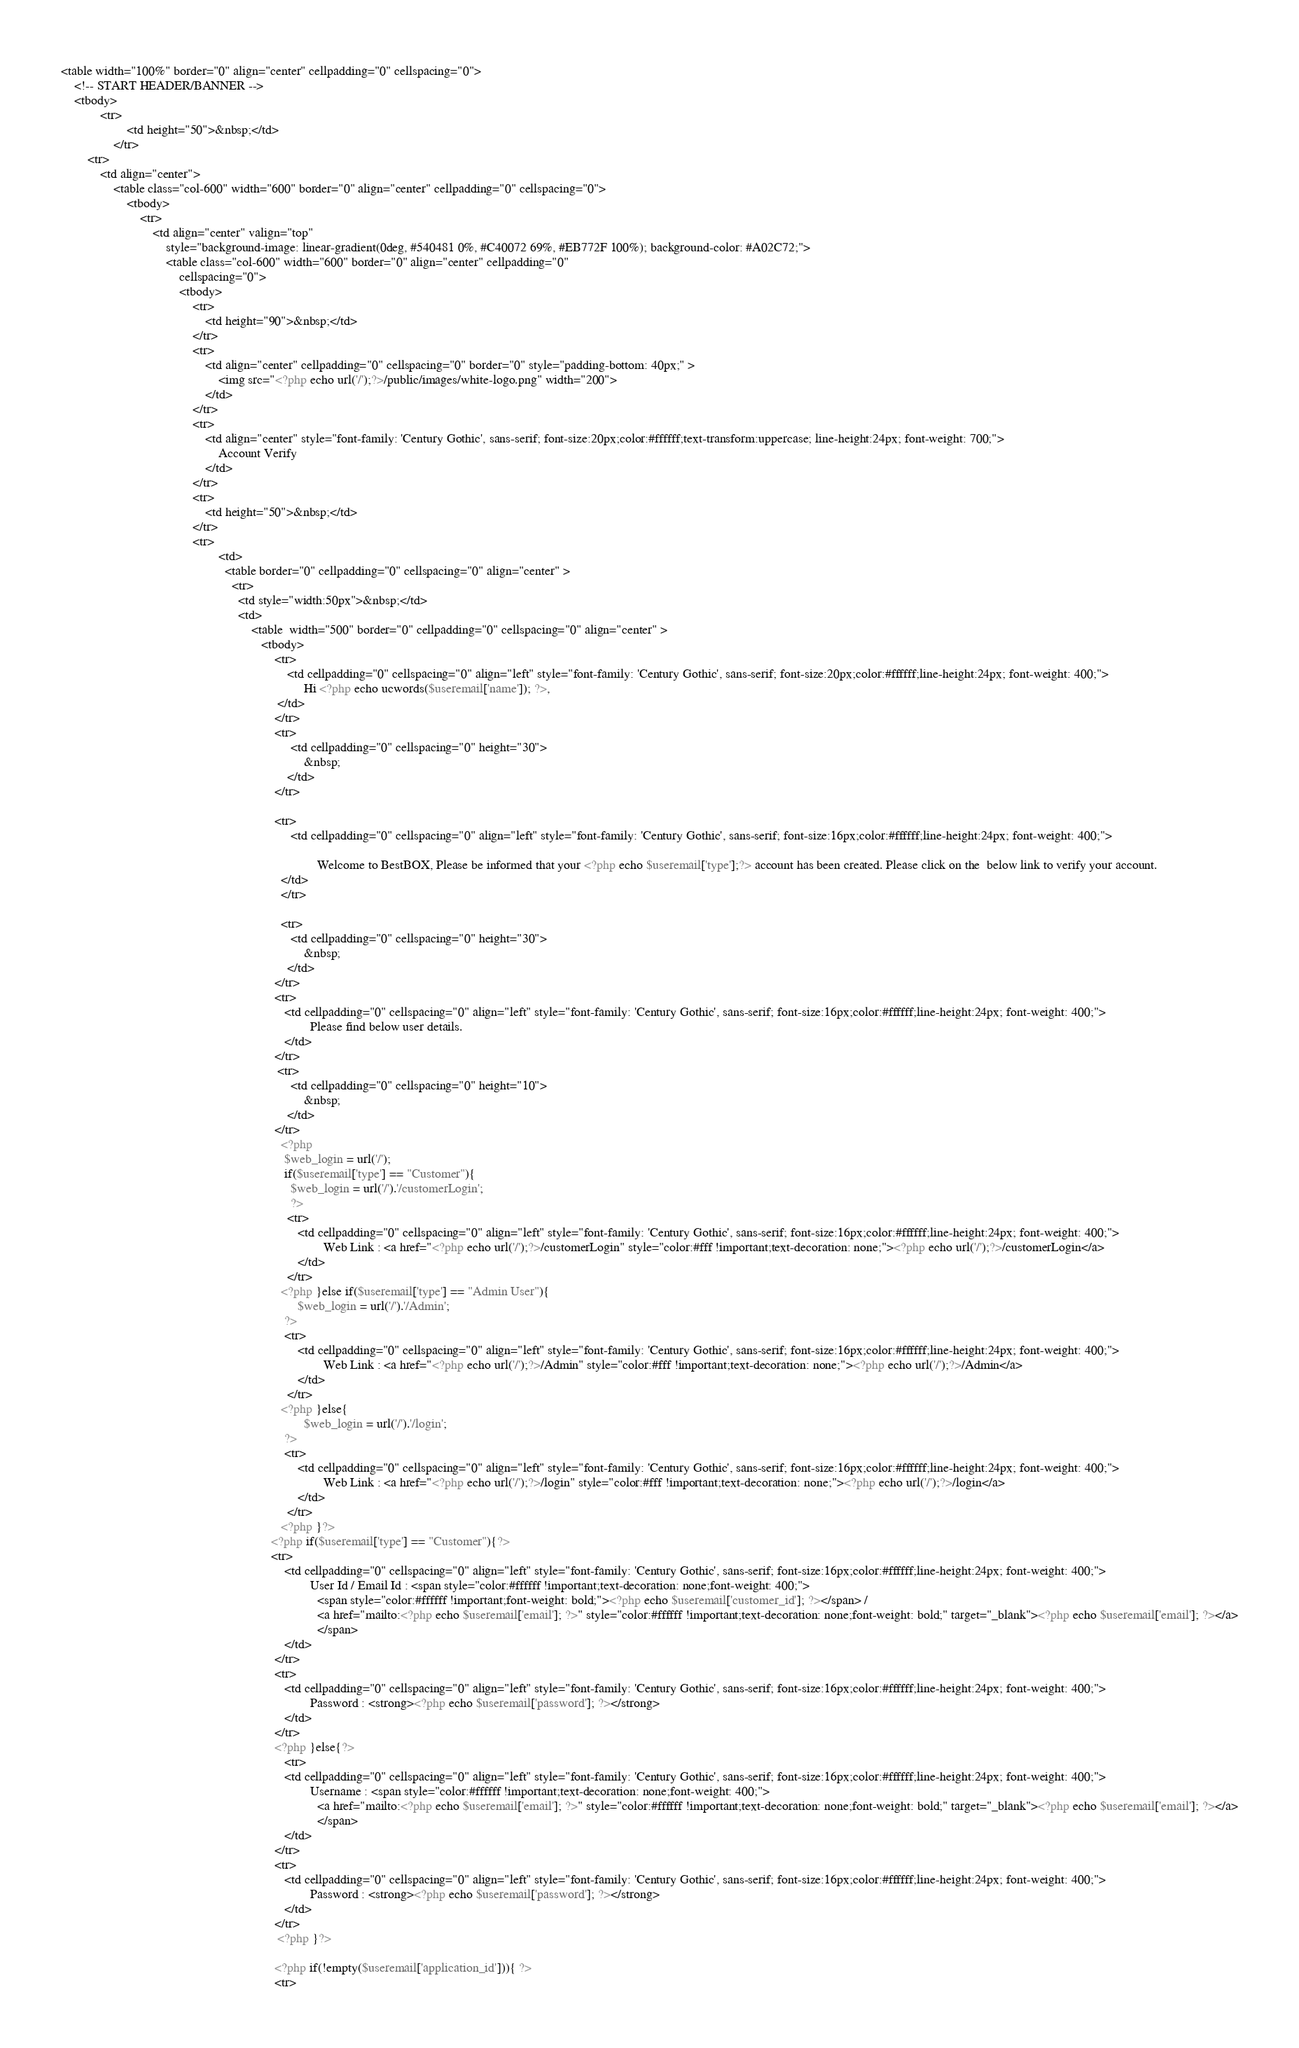Convert code to text. <code><loc_0><loc_0><loc_500><loc_500><_PHP_><table width="100%" border="0" align="center" cellpadding="0" cellspacing="0">
    <!-- START HEADER/BANNER -->
    <tbody>
            <tr>
                    <td height="50">&nbsp;</td>
                </tr>
        <tr>
            <td align="center">
                <table class="col-600" width="600" border="0" align="center" cellpadding="0" cellspacing="0">
                    <tbody>
                        <tr>
                            <td align="center" valign="top"
                                style="background-image: linear-gradient(0deg, #540481 0%, #C40072 69%, #EB772F 100%); background-color: #A02C72;">
                                <table class="col-600" width="600" border="0" align="center" cellpadding="0"
                                    cellspacing="0">
                                    <tbody>
                                        <tr>
                                            <td height="90">&nbsp;</td>
                                        </tr>
                                        <tr>
                                            <td align="center" cellpadding="0" cellspacing="0" border="0" style="padding-bottom: 40px;" >
                                                <img src="<?php echo url('/');?>/public/images/white-logo.png" width="200">
                                            </td>
                                        </tr>
                                        <tr>
                                            <td align="center" style="font-family: 'Century Gothic', sans-serif; font-size:20px;color:#ffffff;text-transform:uppercase; line-height:24px; font-weight: 700;">
                                                Account Verify
                                            </td>
                                        </tr>
                                        <tr>
                                            <td height="50">&nbsp;</td>
                                        </tr>
                                        <tr>
                                                <td>
                                                  <table border="0" cellpadding="0" cellspacing="0" align="center" >
                                                    <tr>
                                                      <td style="width:50px">&nbsp;</td>
                                                      <td>
                                                          <table  width="500" border="0" cellpadding="0" cellspacing="0" align="center" >
                                                             <tbody>
                                                                 <tr>
                                                                     <td cellpadding="0" cellspacing="0" align="left" style="font-family: 'Century Gothic', sans-serif; font-size:20px;color:#ffffff;line-height:24px; font-weight: 400;">
                                                                          Hi <?php echo ucwords($useremail['name']); ?>,
                                                                  </td>
                                                                 </tr>
                                                                 <tr>
                                                                      <td cellpadding="0" cellspacing="0" height="30">
                                                                          &nbsp;
                                                                     </td>
                                                                 </tr>

                                                                 <tr>
                                                                      <td cellpadding="0" cellspacing="0" align="left" style="font-family: 'Century Gothic', sans-serif; font-size:16px;color:#ffffff;line-height:24px; font-weight: 400;">

                                                                              Welcome to BestBOX, Please be informed that your <?php echo $useremail['type'];?> account has been created. Please click on the  below link to verify your account.
                                                                   </td>
                                                                   </tr>

                                                                   <tr>
                                                                      <td cellpadding="0" cellspacing="0" height="30">
                                                                          &nbsp;
                                                                     </td>
                                                                 </tr>
                                                                 <tr>
                                                                    <td cellpadding="0" cellspacing="0" align="left" style="font-family: 'Century Gothic', sans-serif; font-size:16px;color:#ffffff;line-height:24px; font-weight: 400;">
                                                                            Please find below user details.
                                                                    </td>
                                                                 </tr>
                                                                  <tr>
                                                                      <td cellpadding="0" cellspacing="0" height="10">
                                                                          &nbsp;
                                                                     </td>
                                                                 </tr>
                                                                   <?php
                                                                    $web_login = url('/');
                                                                    if($useremail['type'] == "Customer"){
                                                                      $web_login = url('/').'/customerLogin';
                                                                      ?>
                                                                     <tr>
                                                                        <td cellpadding="0" cellspacing="0" align="left" style="font-family: 'Century Gothic', sans-serif; font-size:16px;color:#ffffff;line-height:24px; font-weight: 400;">
                                                                                Web Link : <a href="<?php echo url('/');?>/customerLogin" style="color:#fff !important;text-decoration: none;"><?php echo url('/');?>/customerLogin</a>
                                                                        </td>
                                                                     </tr>
                                                                   <?php }else if($useremail['type'] == "Admin User"){
                                                                        $web_login = url('/').'/Admin';
                                                                    ?>
                                                                    <tr>
                                                                        <td cellpadding="0" cellspacing="0" align="left" style="font-family: 'Century Gothic', sans-serif; font-size:16px;color:#ffffff;line-height:24px; font-weight: 400;">
                                                                                Web Link : <a href="<?php echo url('/');?>/Admin" style="color:#fff !important;text-decoration: none;"><?php echo url('/');?>/Admin</a>
                                                                        </td>
                                                                     </tr>
                                                                   <?php }else{
                                                                          $web_login = url('/').'/login';
                                                                    ?>
                                                                    <tr>
                                                                        <td cellpadding="0" cellspacing="0" align="left" style="font-family: 'Century Gothic', sans-serif; font-size:16px;color:#ffffff;line-height:24px; font-weight: 400;">
                                                                                Web Link : <a href="<?php echo url('/');?>/login" style="color:#fff !important;text-decoration: none;"><?php echo url('/');?>/login</a>
                                                                        </td>
                                                                     </tr>
                                                                   <?php }?>
                                                                <?php if($useremail['type'] == "Customer"){?>
                                                                <tr>
                                                                    <td cellpadding="0" cellspacing="0" align="left" style="font-family: 'Century Gothic', sans-serif; font-size:16px;color:#ffffff;line-height:24px; font-weight: 400;">
                                                                            User Id / Email Id : <span style="color:#ffffff !important;text-decoration: none;font-weight: 400;">
                                                                              <span style="color:#ffffff !important;font-weight: bold;"><?php echo $useremail['customer_id']; ?></span> /
                                                                              <a href="mailto:<?php echo $useremail['email']; ?>" style="color:#ffffff !important;text-decoration: none;font-weight: bold;" target="_blank"><?php echo $useremail['email']; ?></a>
                                                                              </span>
                                                                    </td>
                                                                 </tr>
                                                                 <tr>
                                                                    <td cellpadding="0" cellspacing="0" align="left" style="font-family: 'Century Gothic', sans-serif; font-size:16px;color:#ffffff;line-height:24px; font-weight: 400;">
                                                                            Password : <strong><?php echo $useremail['password']; ?></strong>
                                                                    </td>
                                                                 </tr>
                                                                 <?php }else{?>
                                                                    <tr>
                                                                    <td cellpadding="0" cellspacing="0" align="left" style="font-family: 'Century Gothic', sans-serif; font-size:16px;color:#ffffff;line-height:24px; font-weight: 400;">
                                                                            Username : <span style="color:#ffffff !important;text-decoration: none;font-weight: 400;">
                                                                              <a href="mailto:<?php echo $useremail['email']; ?>" style="color:#ffffff !important;text-decoration: none;font-weight: bold;" target="_blank"><?php echo $useremail['email']; ?></a>
                                                                              </span>
                                                                    </td>
                                                                 </tr>
                                                                 <tr>
                                                                    <td cellpadding="0" cellspacing="0" align="left" style="font-family: 'Century Gothic', sans-serif; font-size:16px;color:#ffffff;line-height:24px; font-weight: 400;">
                                                                            Password : <strong><?php echo $useremail['password']; ?></strong>
                                                                    </td>
                                                                 </tr>
                                                                  <?php }?>

                                                                 <?php if(!empty($useremail['application_id'])){ ?>
                                                                 <tr></code> 